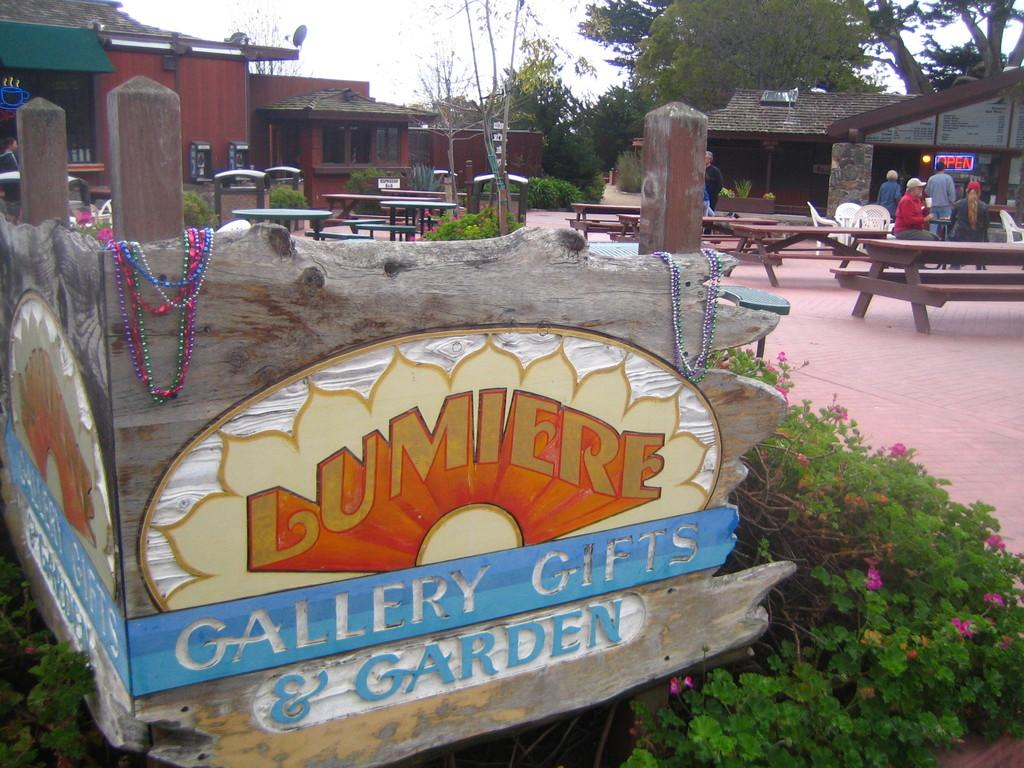What type of setting is depicted in the image? The image is an outdoor scene. What kind of vegetation can be seen in the image? There are plants with flowers and trees visible in the image. Can you describe the structure in the image? There is a building with a roof in the image. What type of furniture is present in the image? There are benches and tables in the image. Are there any people visible in the image? Yes, there are people standing far away in the image. What type of bone can be seen in the image? There is no bone present in the image. How many robins are perched on the trees in the image? There are no robins visible in the image; only plants, trees, a building, furniture, and people can be seen. 